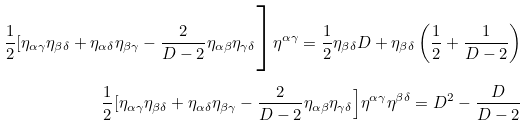Convert formula to latex. <formula><loc_0><loc_0><loc_500><loc_500>\frac { 1 } { 2 } [ \eta _ { \alpha \gamma } \eta _ { \beta \delta } + \eta _ { \alpha \delta } \eta _ { \beta \gamma } - \frac { 2 } { D - 2 } \eta _ { \alpha \beta } \eta _ { \gamma \delta } \Big ] \eta ^ { \alpha \gamma } = \frac { 1 } { 2 } \eta _ { \beta \delta } D + \eta _ { \beta \delta } \left ( \frac { 1 } { 2 } + \frac { 1 } { D - 2 } \right ) \\ \frac { 1 } { 2 } [ \eta _ { \alpha \gamma } \eta _ { \beta \delta } + \eta _ { \alpha \delta } \eta _ { \beta \gamma } - \frac { 2 } { D - 2 } \eta _ { \alpha \beta } \eta _ { \gamma \delta } \Big ] \eta ^ { \alpha \gamma } \eta ^ { \beta \delta } = D ^ { 2 } - \frac { D } { D - 2 }</formula> 